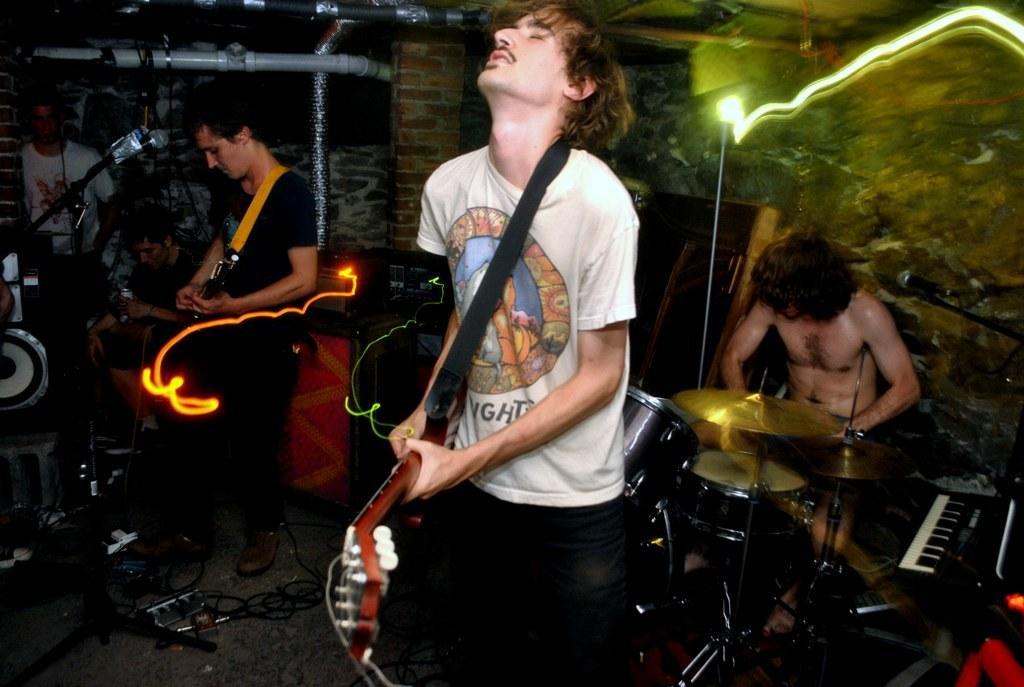How would you summarize this image in a sentence or two? This picture consists of a group of musicians performing. In the center a man wearing a white colour shirt is holding a musical instrument in his hand. At the right side the man is sitting in front of the musical instrument. At the left side the man is standing. In the background a white colour shirt t-shirt the man which he is wearing is standing in front of the instrument. There is a wall in the background. On the floor there are wires. At the left side there are speakers. At the right side there is a musical instrument kept on the bench. 